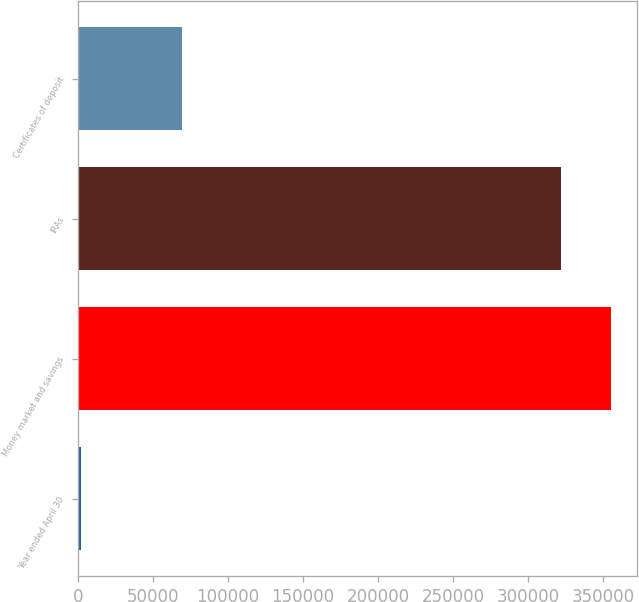<chart> <loc_0><loc_0><loc_500><loc_500><bar_chart><fcel>Year ended April 30<fcel>Money market and savings<fcel>IRAs<fcel>Certificates of deposit<nl><fcel>2013<fcel>355059<fcel>322078<fcel>69444<nl></chart> 